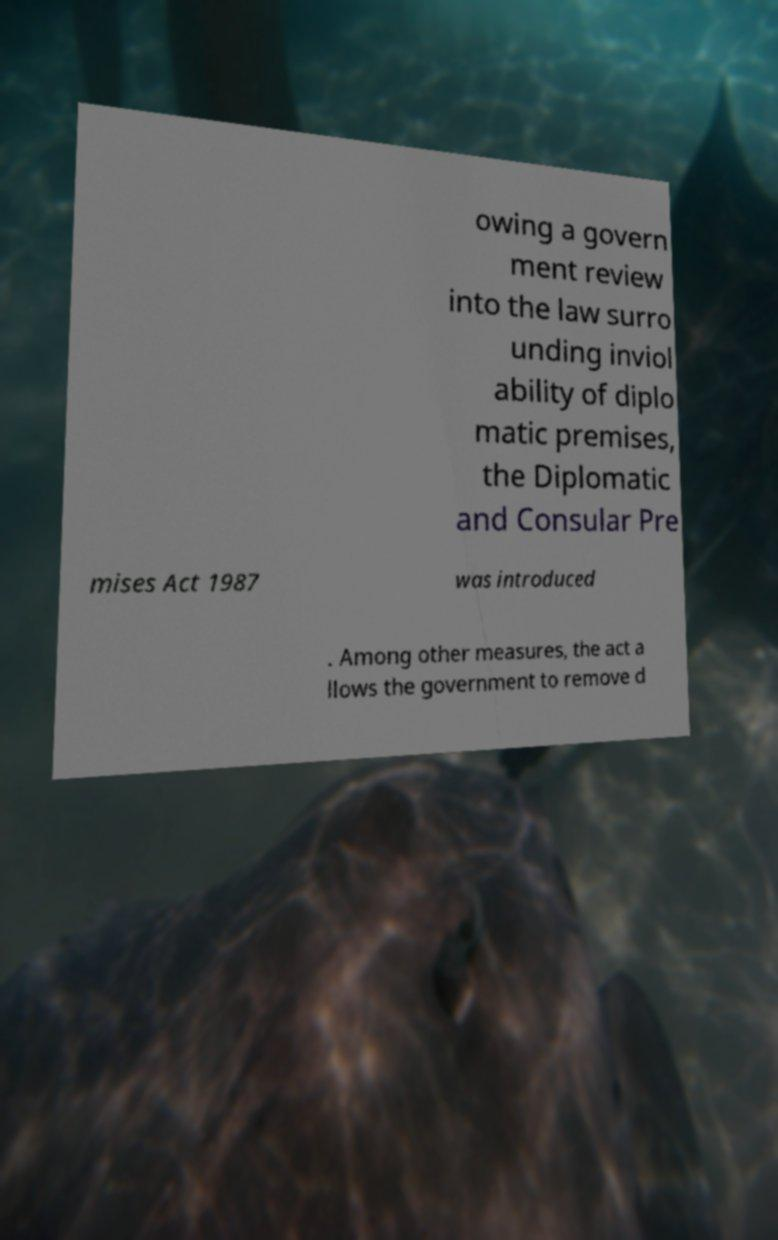Could you assist in decoding the text presented in this image and type it out clearly? owing a govern ment review into the law surro unding inviol ability of diplo matic premises, the Diplomatic and Consular Pre mises Act 1987 was introduced . Among other measures, the act a llows the government to remove d 